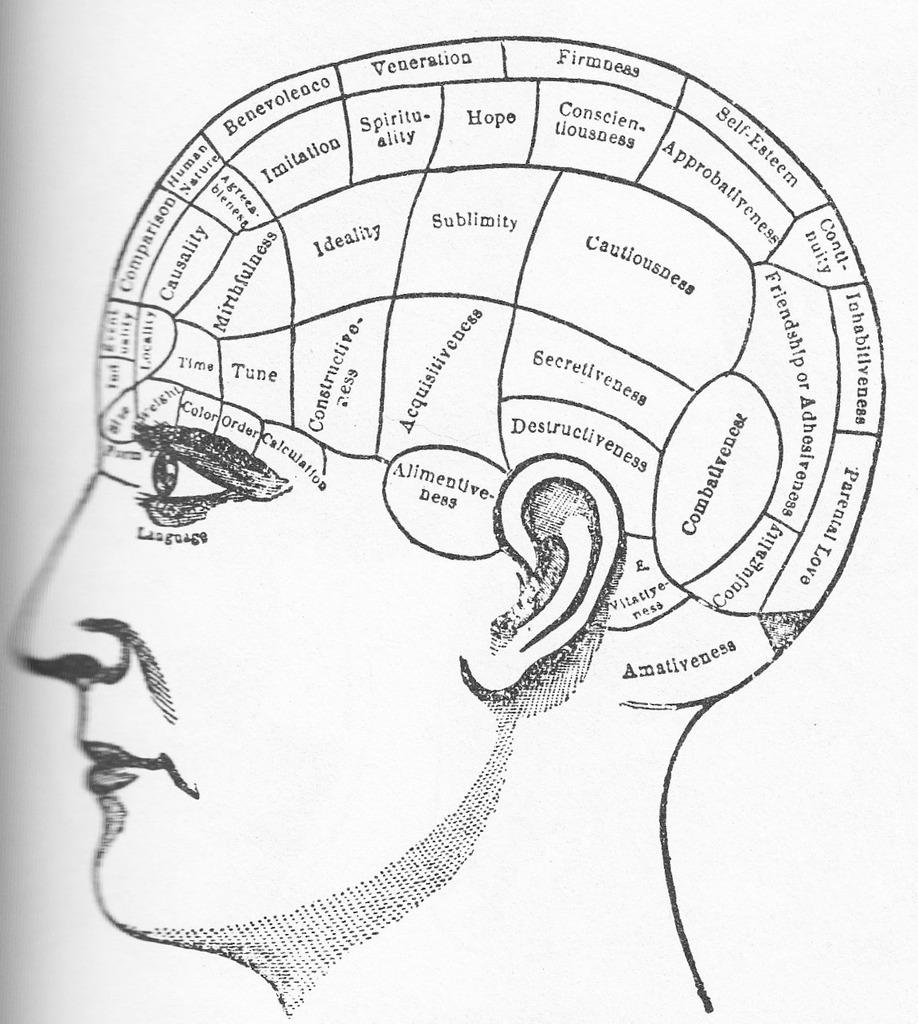What is the main subject of the image? The main subject of the image is a diagram of a person's head. What color scheme is used in the image? The image is in black and white. What additional information is provided with the diagram? There is text associated with the diagram. What day of the week is depicted in the image? The image does not depict a day of the week; it is a diagram of a person's head. What type of advertisement is shown in the image? There is no advertisement present in the image; it is a diagram of a person's head with associated text. 